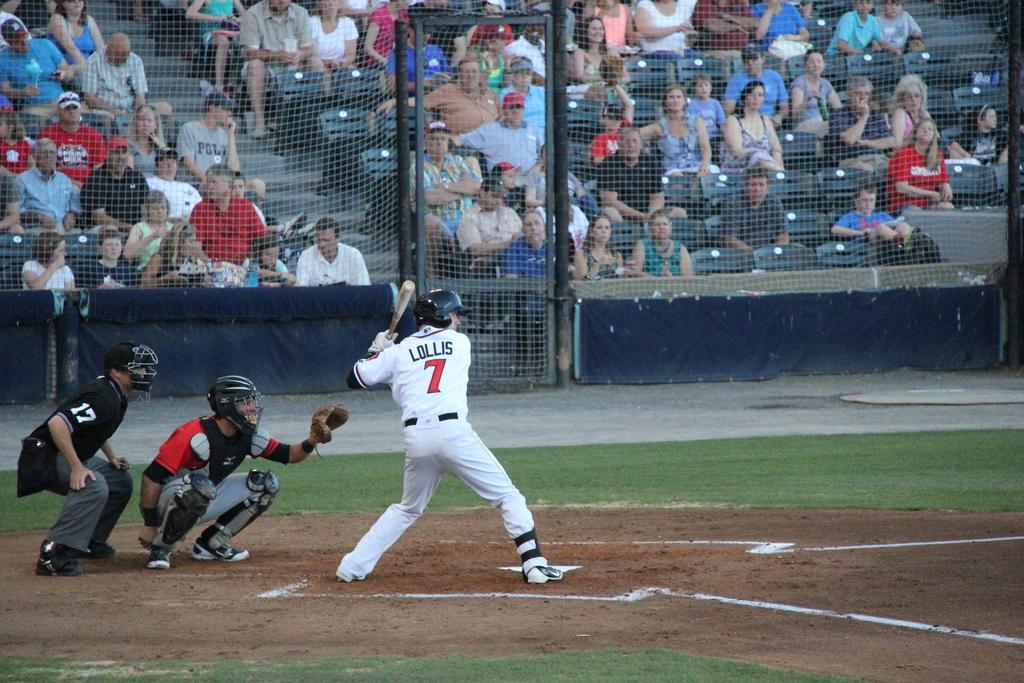<image>
Create a compact narrative representing the image presented. Professional baseball player Lollis number seven up to bat. 